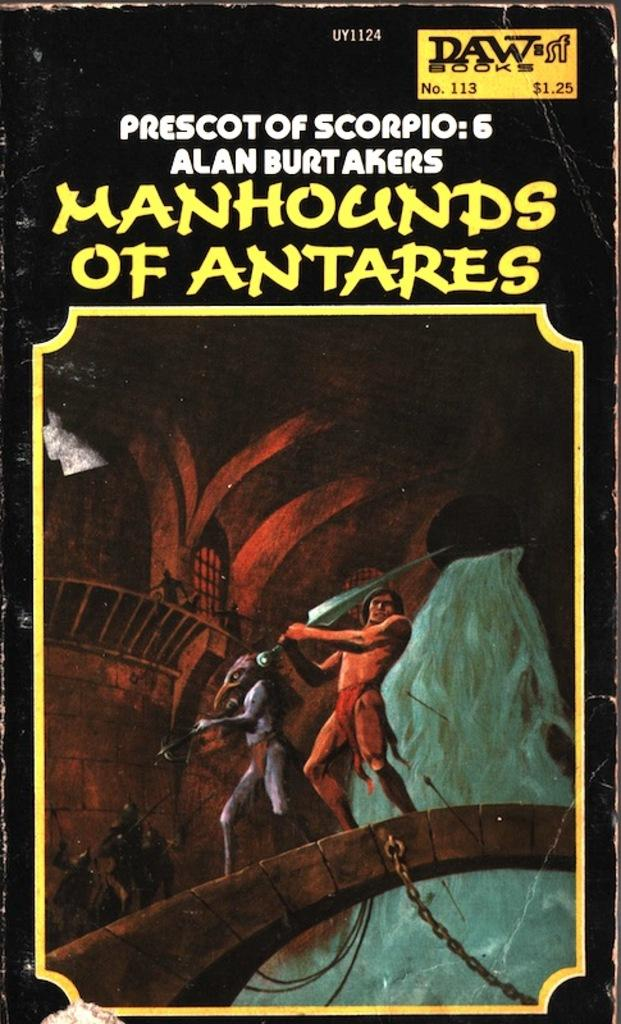<image>
Summarize the visual content of the image. A book is priced for one dollar and twenty five cents and has a man with a sword on the cover. 